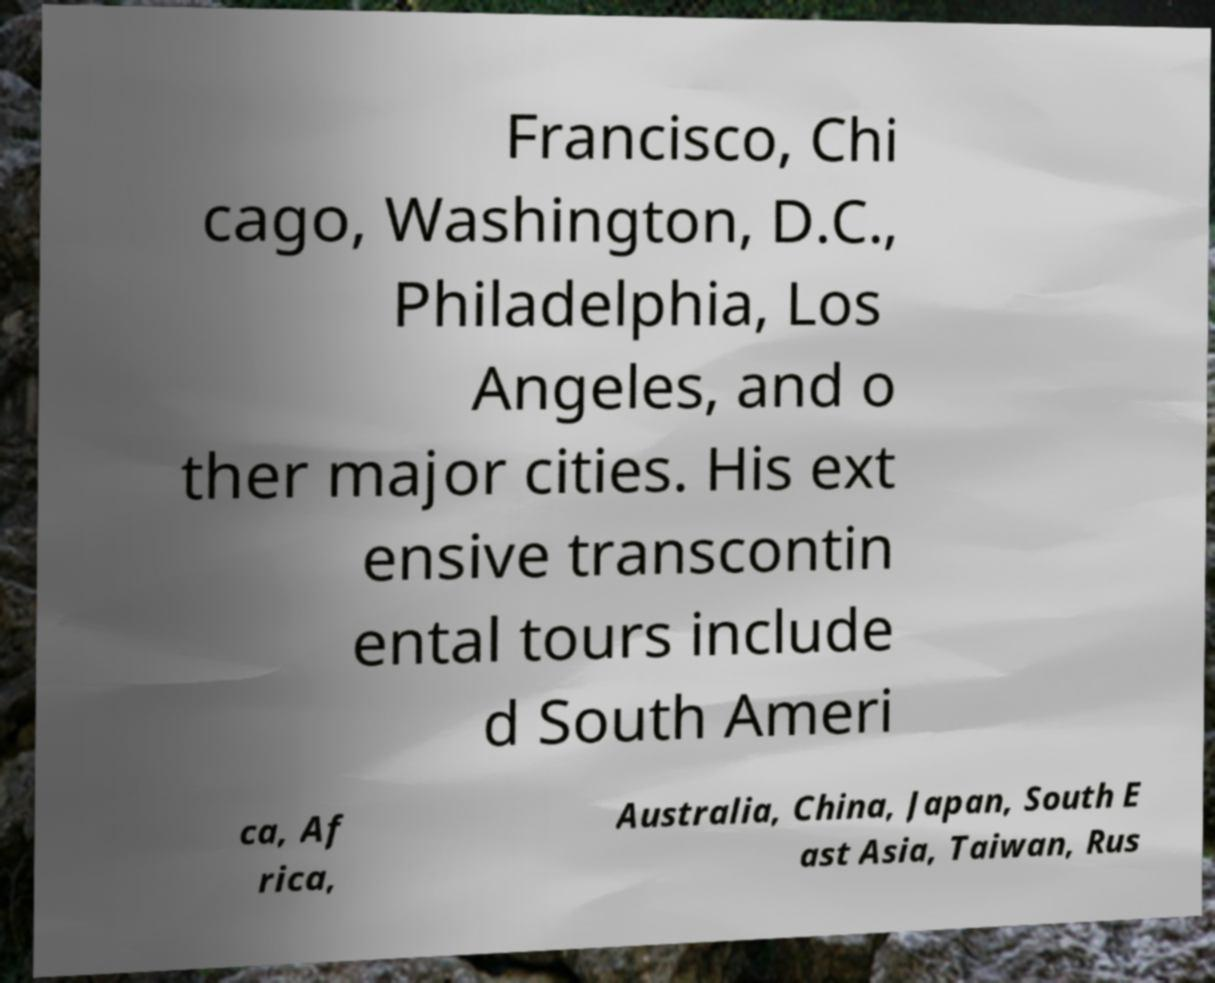For documentation purposes, I need the text within this image transcribed. Could you provide that? Francisco, Chi cago, Washington, D.C., Philadelphia, Los Angeles, and o ther major cities. His ext ensive transcontin ental tours include d South Ameri ca, Af rica, Australia, China, Japan, South E ast Asia, Taiwan, Rus 